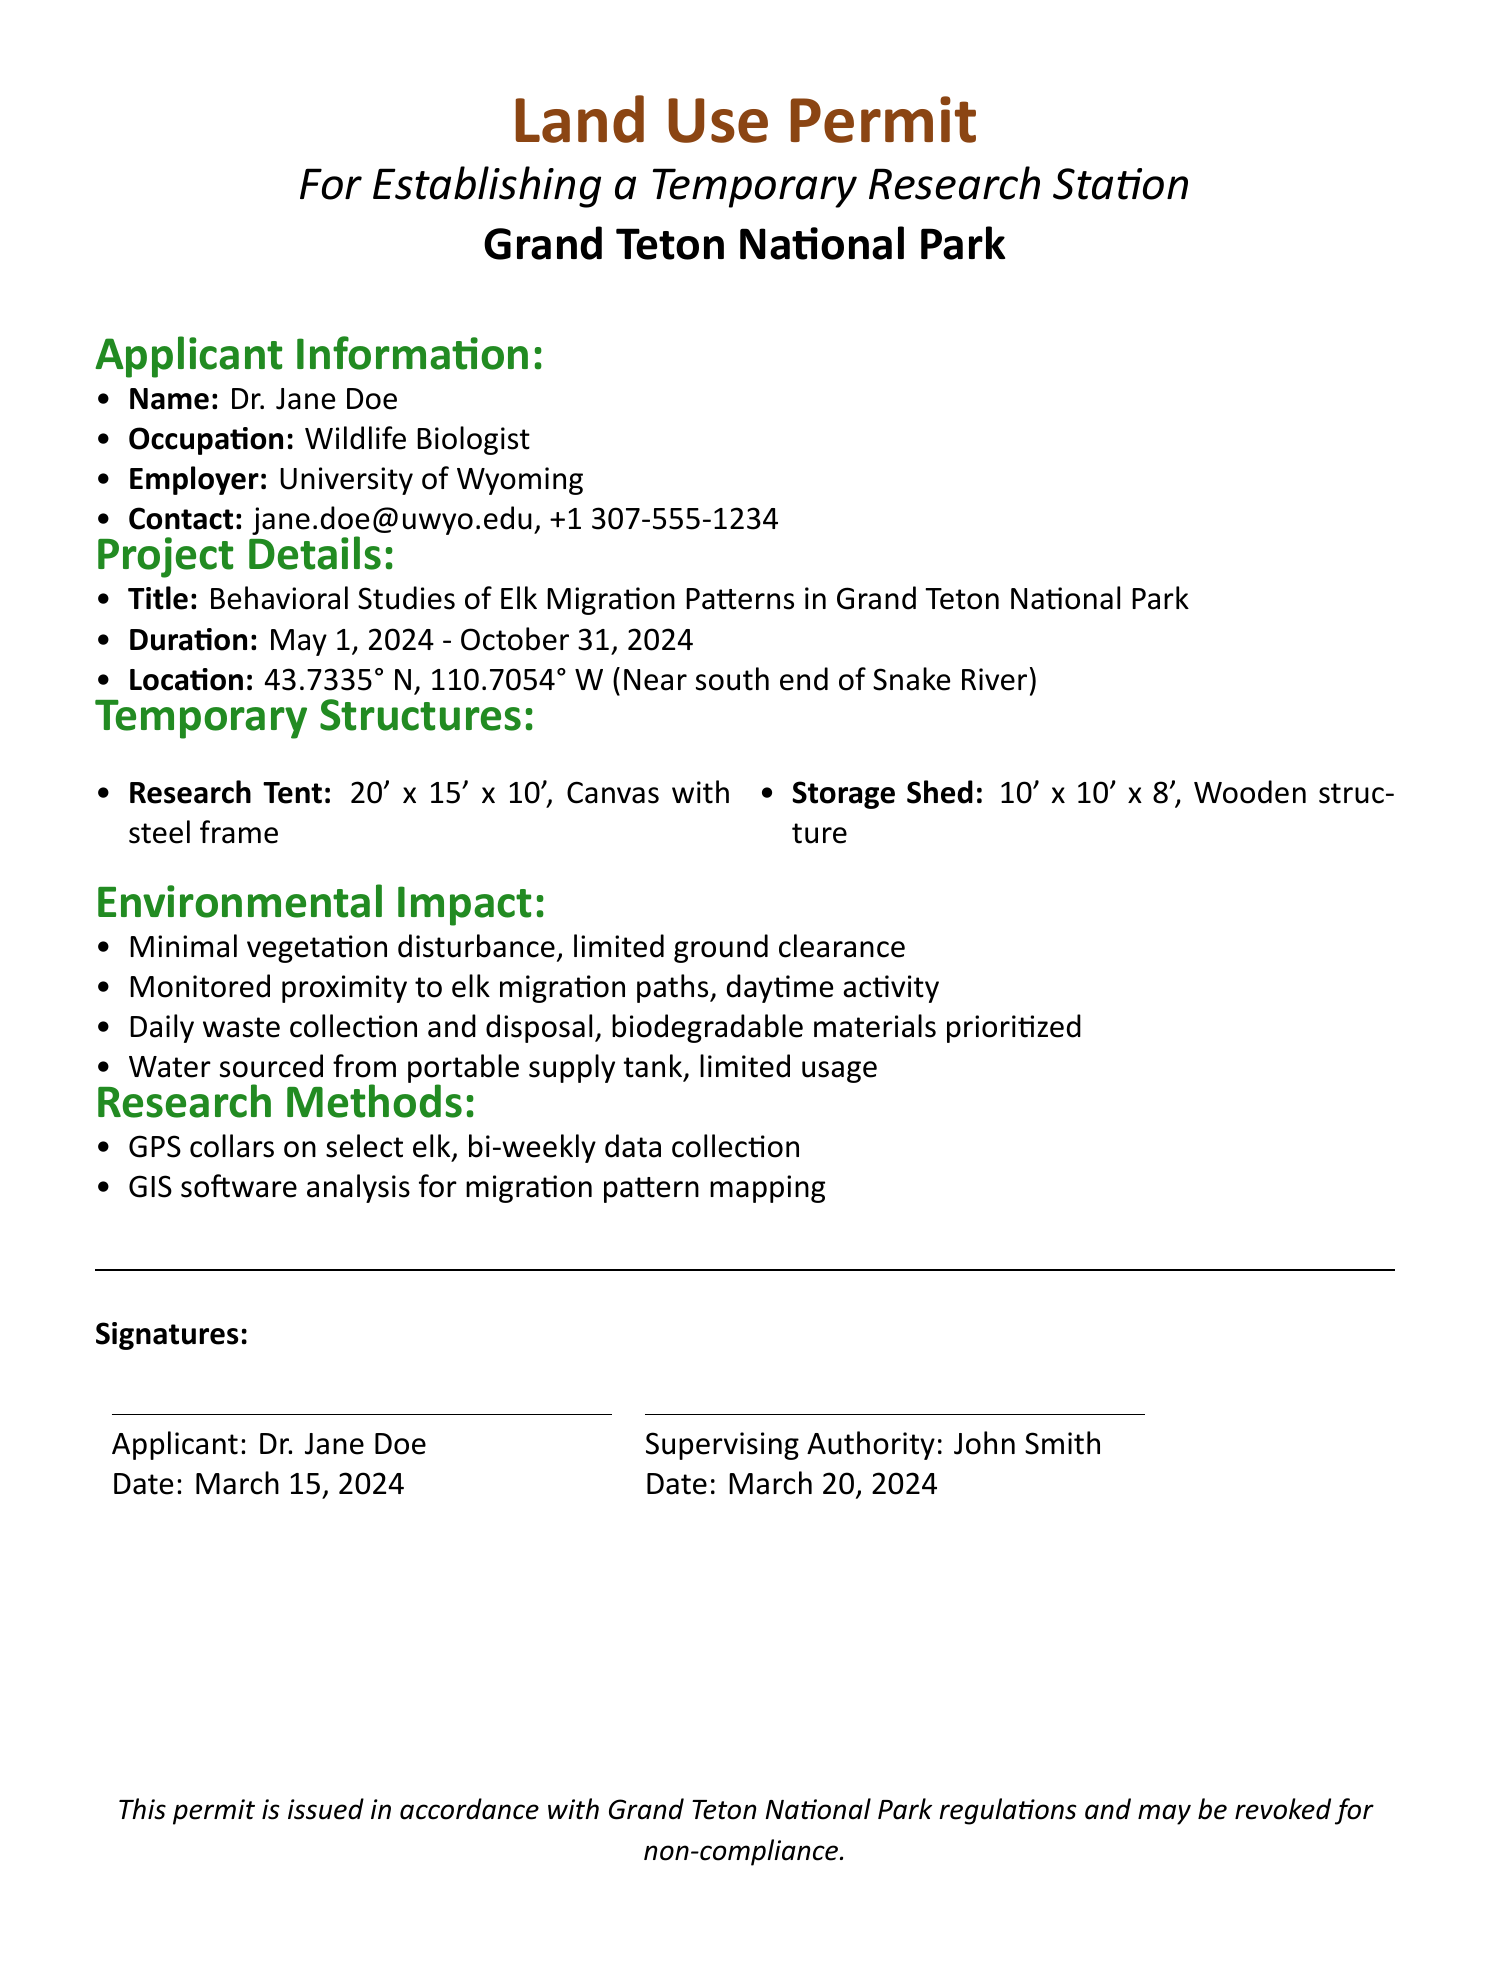What is the name of the applicant? The name of the applicant is stated in the document under Applicant Information as Dr. Jane Doe.
Answer: Dr. Jane Doe What is the occupation of Dr. Jane Doe? The occupation of the applicant is specified as Wildlife Biologist in the Applicant Information section.
Answer: Wildlife Biologist What is the location of the temporary research station? The exact location coordinates are provided in the document, specifically in the Project Details section.
Answer: 43.7335° N, 110.7054° W What is the size of the research tent? The dimensions of the research tent are listed in the Temporary Structures section of the document.
Answer: 20' x 15' x 10' What is the duration of the project? The duration of the project is stated in the Project Details section with specific start and end dates.
Answer: May 1, 2024 - October 31, 2024 What type of materials are prioritized for waste disposal? The document indicates a preference regarding waste material types in the Environmental Impact section.
Answer: Biodegradable materials How will waste be managed according to the document? Waste management practices are outlined in the Environmental Impact section, specifying a procedure for collection.
Answer: Daily waste collection and disposal What is the purpose of the research station as outlined in the document? The purpose is defined in the Project Details section detailing the specific study focus.
Answer: Behavioral Studies of Elk Migration Patterns Who is the supervising authority listed in the document? The supervising authority's name is provided in the Signatures section at the end of the document.
Answer: John Smith 